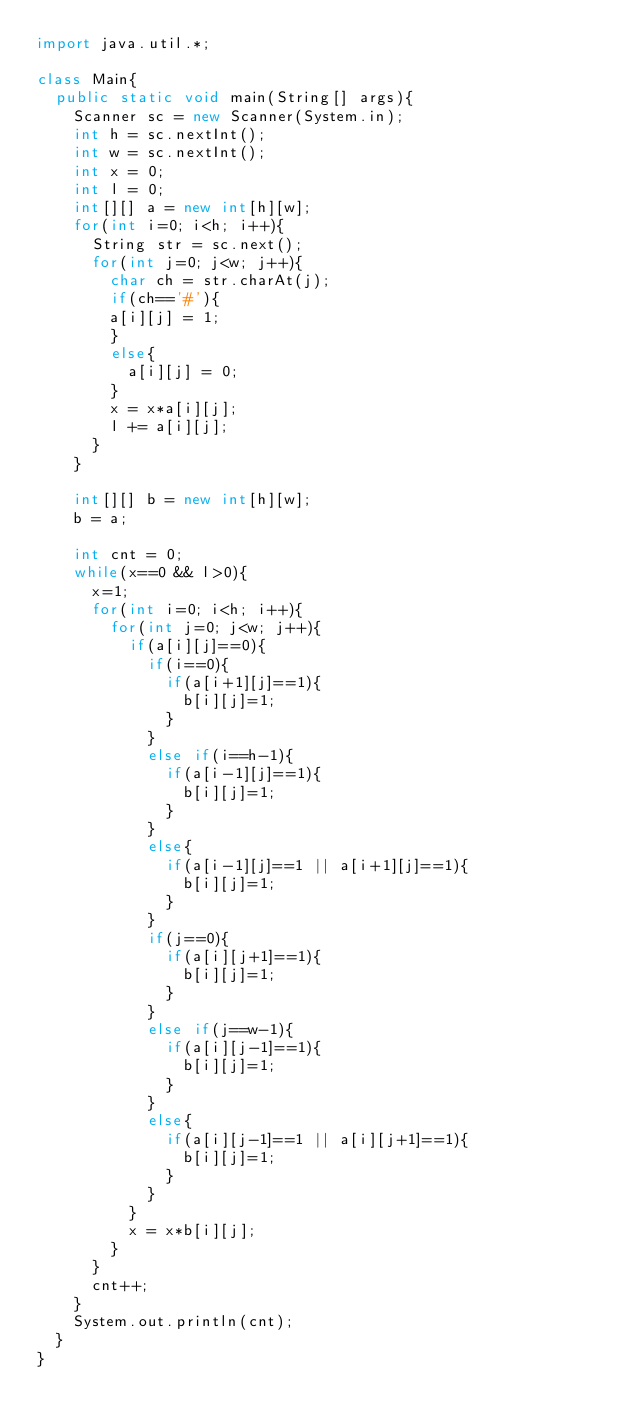Convert code to text. <code><loc_0><loc_0><loc_500><loc_500><_Java_>import java.util.*;

class Main{
  public static void main(String[] args){
    Scanner sc = new Scanner(System.in);
    int h = sc.nextInt();
    int w = sc.nextInt();
    int x = 0;
    int l = 0;
    int[][] a = new int[h][w];
    for(int i=0; i<h; i++){
      String str = sc.next();
      for(int j=0; j<w; j++){
        char ch = str.charAt(j);
        if(ch=='#'){
        a[i][j] = 1;
        }
        else{
          a[i][j] = 0;
        }
        x = x*a[i][j];
        l += a[i][j];
      }
    }
    
    int[][] b = new int[h][w];
    b = a;
    
    int cnt = 0;      
    while(x==0 && l>0){
      x=1;
      for(int i=0; i<h; i++){
        for(int j=0; j<w; j++){
          if(a[i][j]==0){
            if(i==0){
              if(a[i+1][j]==1){
                b[i][j]=1;
              }
            }
            else if(i==h-1){
              if(a[i-1][j]==1){
                b[i][j]=1;
              }
            }
            else{
              if(a[i-1][j]==1 || a[i+1][j]==1){
                b[i][j]=1;
              }
            }
            if(j==0){
              if(a[i][j+1]==1){
                b[i][j]=1;
              }
            }
            else if(j==w-1){
              if(a[i][j-1]==1){
                b[i][j]=1;
              }
            }
            else{
              if(a[i][j-1]==1 || a[i][j+1]==1){
                b[i][j]=1;
              }
            }
          }
          x = x*b[i][j];
        }
      }
      cnt++;
    }
    System.out.println(cnt);
  }
}</code> 